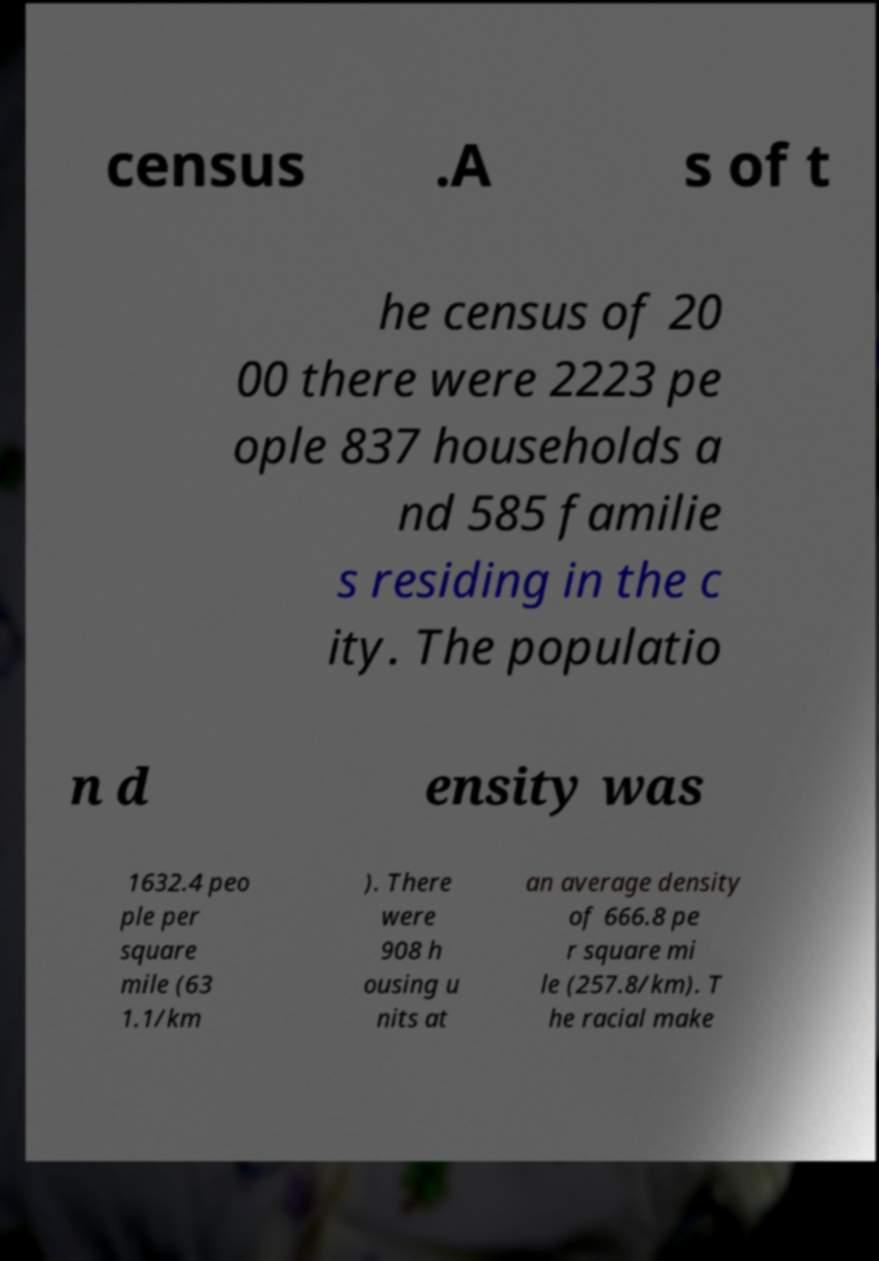Can you accurately transcribe the text from the provided image for me? census .A s of t he census of 20 00 there were 2223 pe ople 837 households a nd 585 familie s residing in the c ity. The populatio n d ensity was 1632.4 peo ple per square mile (63 1.1/km ). There were 908 h ousing u nits at an average density of 666.8 pe r square mi le (257.8/km). T he racial make 